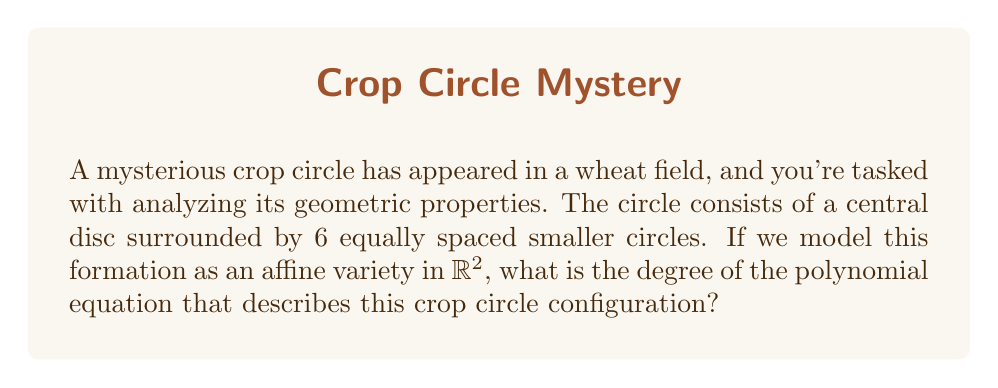Show me your answer to this math problem. Let's approach this step-by-step:

1) In algebraic geometry, an affine variety is the set of solutions of a system of polynomial equations. In this case, we're working in $\mathbb{R}^2$.

2) To describe a circle in $\mathbb{R}^2$, we use the equation:
   $$(x-h)^2 + (y-k)^2 = r^2$$
   where $(h,k)$ is the center and $r$ is the radius.

3) For our crop circle formation, we need to describe:
   - One large central circle
   - Six smaller circles arranged around it

4) Let's say the central circle has radius $R$ and is centered at the origin $(0,0)$. Its equation is:
   $$x^2 + y^2 = R^2$$

5) For the surrounding circles, let's assume they have radius $r$ and are centered at $(R\cos(\theta_i), R\sin(\theta_i))$ where $\theta_i = \frac{2\pi i}{6}$ for $i = 0, 1, 2, 3, 4, 5$.

6) The equation for each of these circles is:
   $$(x - R\cos(\theta_i))^2 + (y - R\sin(\theta_i))^2 = r^2$$

7) To describe the entire formation, we need the product of all these equations (one for the central circle and six for the surrounding circles):

   $$f(x,y) = (x^2 + y^2 - R^2) \prod_{i=0}^5 ((x - R\cos(\theta_i))^2 + (y - R\sin(\theta_i))^2 - r^2) = 0$$

8) Each circle equation is of degree 2. When we multiply these equations, the degrees add.

9) Therefore, the total degree of the polynomial $f(x,y)$ is:
   $$2 + 6 \cdot 2 = 14$$

Thus, the crop circle configuration can be described by a polynomial equation of degree 14.
Answer: 14 